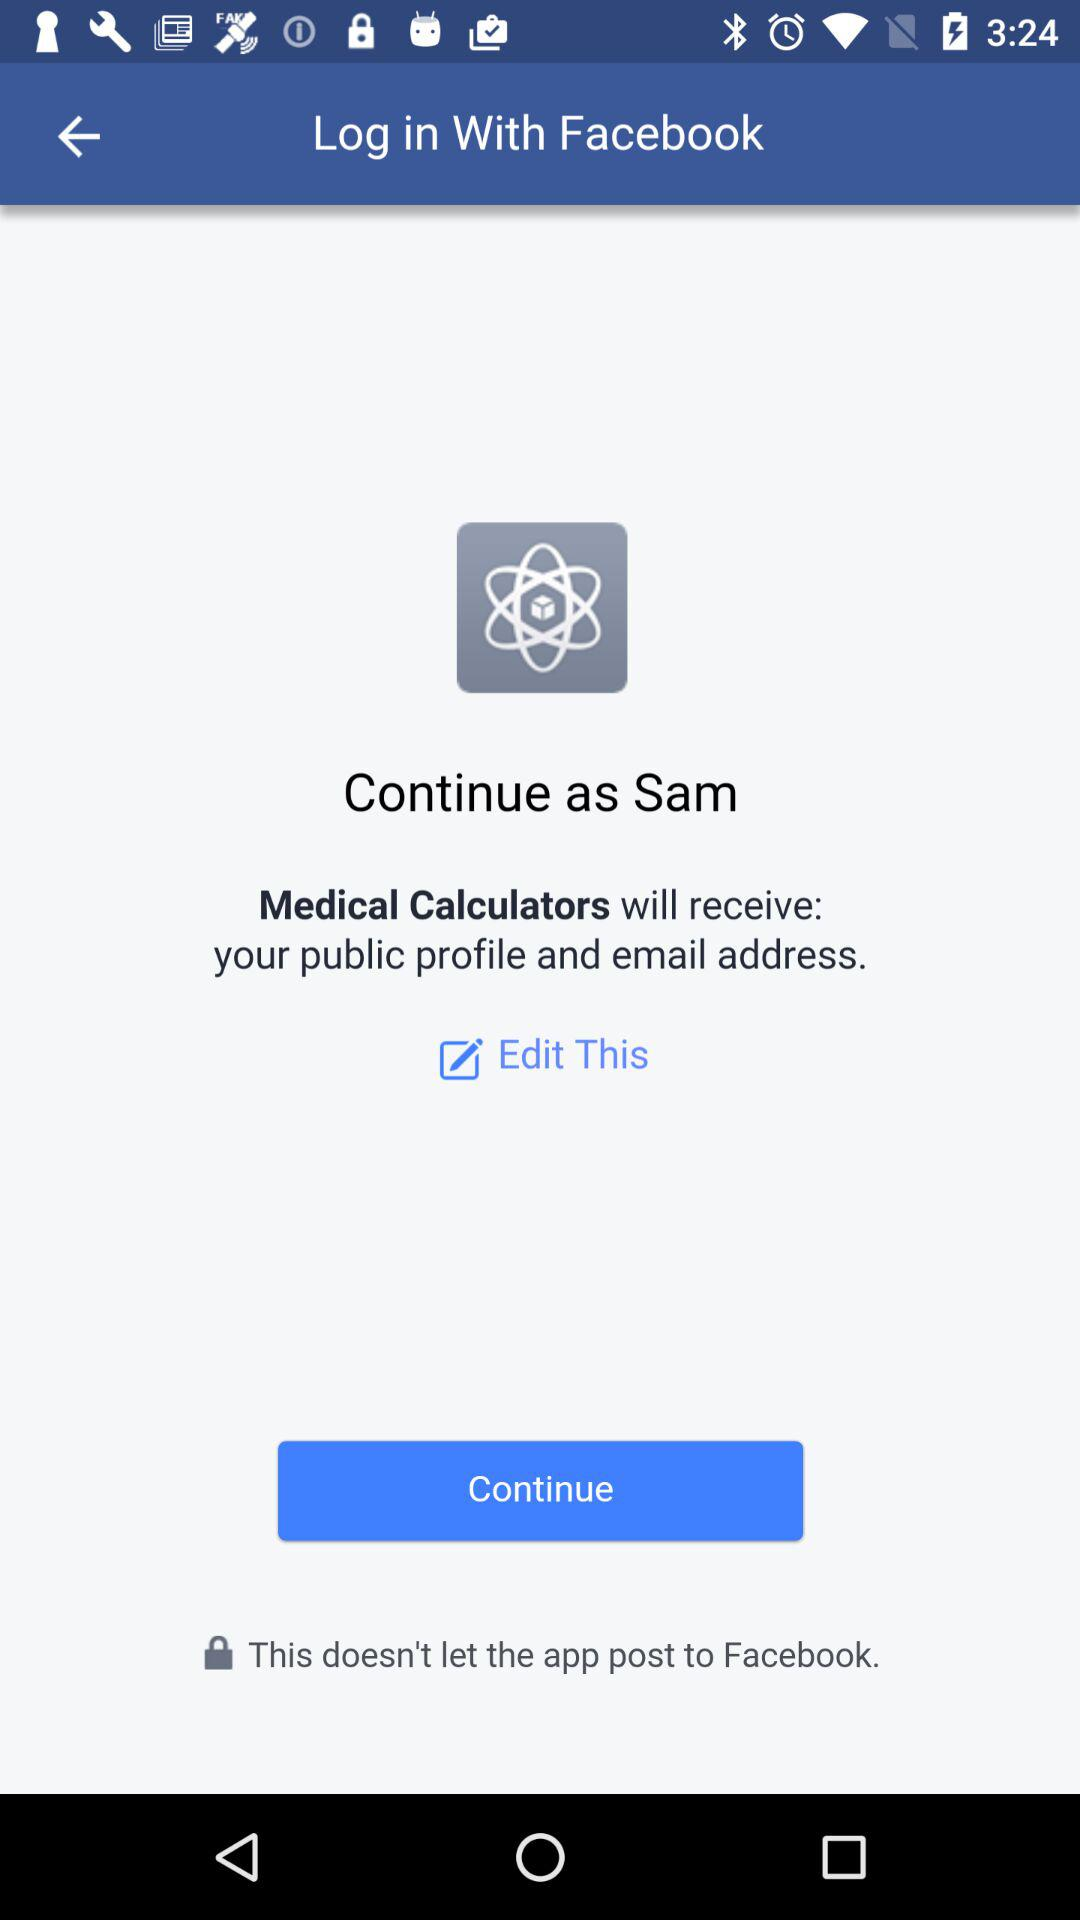What application will receive my public profile and email address? The application that will receive your public profile and email address is "Medical Calculators". 